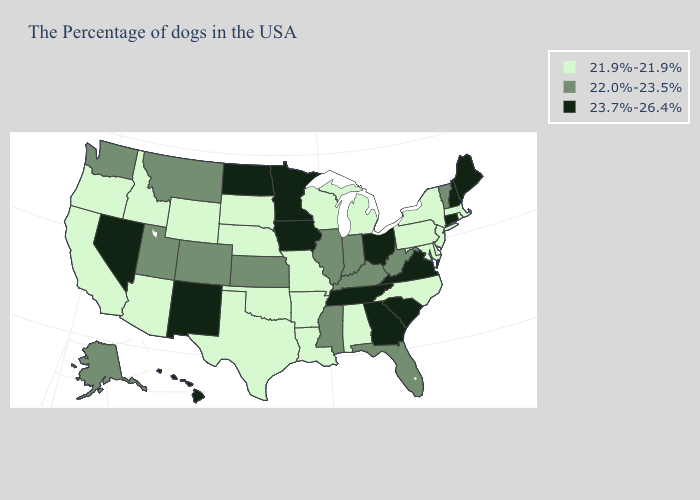Name the states that have a value in the range 21.9%-21.9%?
Concise answer only. Massachusetts, Rhode Island, New York, New Jersey, Delaware, Maryland, Pennsylvania, North Carolina, Michigan, Alabama, Wisconsin, Louisiana, Missouri, Arkansas, Nebraska, Oklahoma, Texas, South Dakota, Wyoming, Arizona, Idaho, California, Oregon. What is the value of Nevada?
Answer briefly. 23.7%-26.4%. Which states hav the highest value in the Northeast?
Answer briefly. Maine, New Hampshire, Connecticut. Among the states that border Pennsylvania , which have the highest value?
Give a very brief answer. Ohio. Which states have the lowest value in the Northeast?
Answer briefly. Massachusetts, Rhode Island, New York, New Jersey, Pennsylvania. Does the map have missing data?
Answer briefly. No. Does Iowa have a higher value than Georgia?
Concise answer only. No. What is the value of Indiana?
Answer briefly. 22.0%-23.5%. Name the states that have a value in the range 22.0%-23.5%?
Quick response, please. Vermont, West Virginia, Florida, Kentucky, Indiana, Illinois, Mississippi, Kansas, Colorado, Utah, Montana, Washington, Alaska. Name the states that have a value in the range 23.7%-26.4%?
Quick response, please. Maine, New Hampshire, Connecticut, Virginia, South Carolina, Ohio, Georgia, Tennessee, Minnesota, Iowa, North Dakota, New Mexico, Nevada, Hawaii. Name the states that have a value in the range 22.0%-23.5%?
Answer briefly. Vermont, West Virginia, Florida, Kentucky, Indiana, Illinois, Mississippi, Kansas, Colorado, Utah, Montana, Washington, Alaska. Name the states that have a value in the range 21.9%-21.9%?
Keep it brief. Massachusetts, Rhode Island, New York, New Jersey, Delaware, Maryland, Pennsylvania, North Carolina, Michigan, Alabama, Wisconsin, Louisiana, Missouri, Arkansas, Nebraska, Oklahoma, Texas, South Dakota, Wyoming, Arizona, Idaho, California, Oregon. Does Washington have a higher value than North Dakota?
Keep it brief. No. What is the value of Louisiana?
Be succinct. 21.9%-21.9%. What is the highest value in states that border Vermont?
Keep it brief. 23.7%-26.4%. 